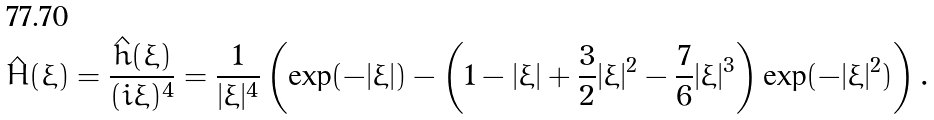Convert formula to latex. <formula><loc_0><loc_0><loc_500><loc_500>\hat { H } ( \xi ) = \frac { \hat { h } ( \xi ) } { ( i \xi ) ^ { 4 } } = \frac { 1 } { | \xi | ^ { 4 } } \left ( \exp ( - | \xi | ) - \left ( 1 - | \xi | + \frac { 3 } { 2 } | \xi | ^ { 2 } - \frac { 7 } { 6 } | \xi | ^ { 3 } \right ) \exp ( - | \xi | ^ { 2 } ) \right ) .</formula> 